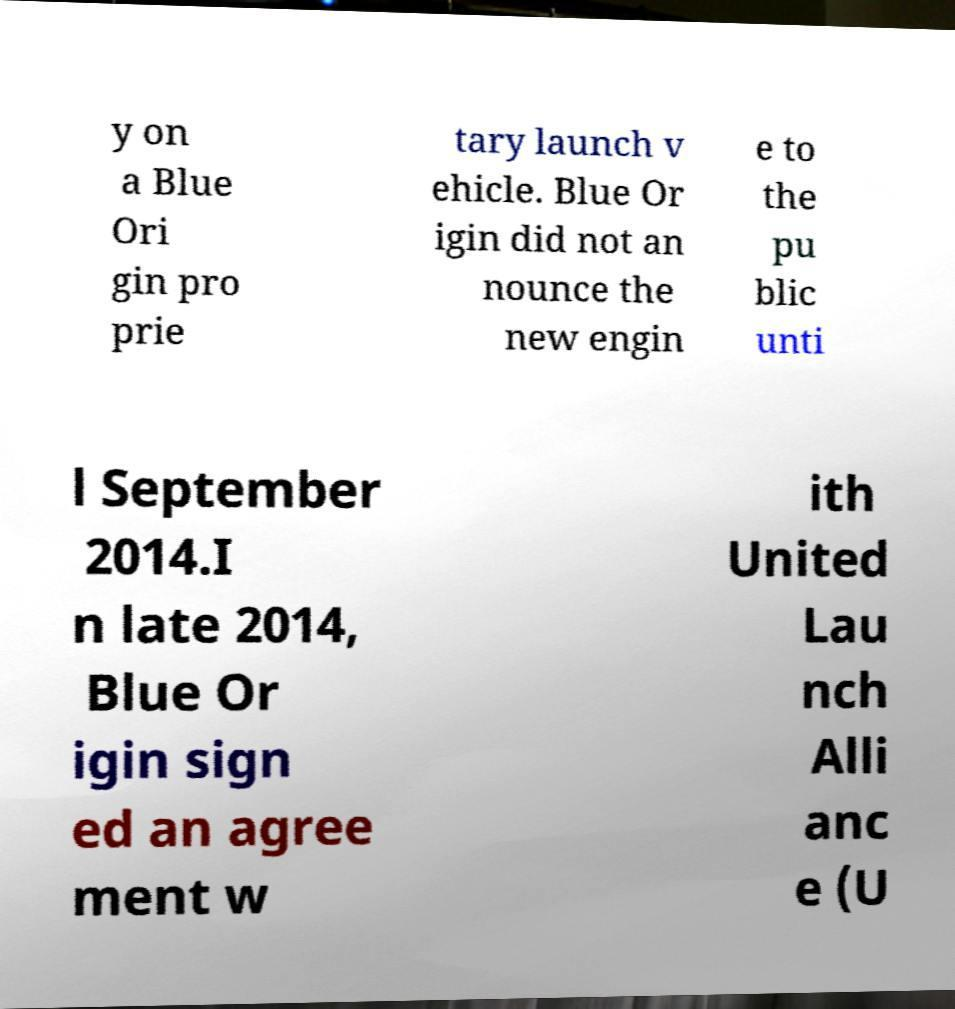Could you extract and type out the text from this image? y on a Blue Ori gin pro prie tary launch v ehicle. Blue Or igin did not an nounce the new engin e to the pu blic unti l September 2014.I n late 2014, Blue Or igin sign ed an agree ment w ith United Lau nch Alli anc e (U 